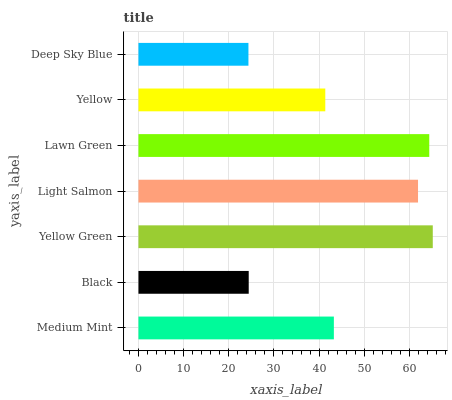Is Deep Sky Blue the minimum?
Answer yes or no. Yes. Is Yellow Green the maximum?
Answer yes or no. Yes. Is Black the minimum?
Answer yes or no. No. Is Black the maximum?
Answer yes or no. No. Is Medium Mint greater than Black?
Answer yes or no. Yes. Is Black less than Medium Mint?
Answer yes or no. Yes. Is Black greater than Medium Mint?
Answer yes or no. No. Is Medium Mint less than Black?
Answer yes or no. No. Is Medium Mint the high median?
Answer yes or no. Yes. Is Medium Mint the low median?
Answer yes or no. Yes. Is Deep Sky Blue the high median?
Answer yes or no. No. Is Deep Sky Blue the low median?
Answer yes or no. No. 